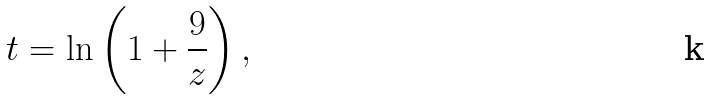Convert formula to latex. <formula><loc_0><loc_0><loc_500><loc_500>t = \ln \left ( 1 + \frac { 9 } { z } \right ) ,</formula> 